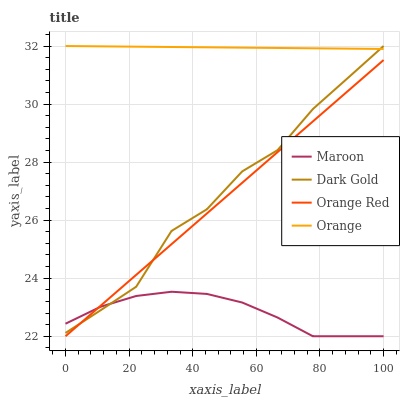Does Maroon have the minimum area under the curve?
Answer yes or no. Yes. Does Orange have the maximum area under the curve?
Answer yes or no. Yes. Does Orange Red have the minimum area under the curve?
Answer yes or no. No. Does Orange Red have the maximum area under the curve?
Answer yes or no. No. Is Orange Red the smoothest?
Answer yes or no. Yes. Is Dark Gold the roughest?
Answer yes or no. Yes. Is Maroon the smoothest?
Answer yes or no. No. Is Maroon the roughest?
Answer yes or no. No. Does Orange Red have the lowest value?
Answer yes or no. Yes. Does Dark Gold have the lowest value?
Answer yes or no. No. Does Dark Gold have the highest value?
Answer yes or no. Yes. Does Orange Red have the highest value?
Answer yes or no. No. Is Orange Red less than Orange?
Answer yes or no. Yes. Is Orange greater than Orange Red?
Answer yes or no. Yes. Does Dark Gold intersect Orange Red?
Answer yes or no. Yes. Is Dark Gold less than Orange Red?
Answer yes or no. No. Is Dark Gold greater than Orange Red?
Answer yes or no. No. Does Orange Red intersect Orange?
Answer yes or no. No. 